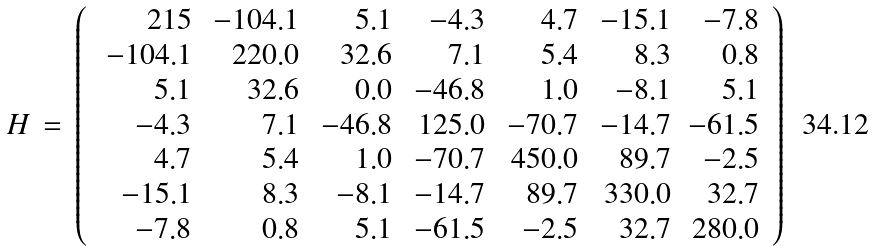<formula> <loc_0><loc_0><loc_500><loc_500>H \, = \, \left ( \, \begin{array} { r r r r r r r } 2 1 5 & \, - 1 0 4 . 1 & 5 . 1 & - 4 . 3 & 4 . 7 & - 1 5 . 1 & - 7 . 8 \\ \, - 1 0 4 . 1 & 2 2 0 . 0 & 3 2 . 6 & 7 . 1 & 5 . 4 & 8 . 3 & 0 . 8 \\ 5 . 1 & 3 2 . 6 & 0 . 0 & - 4 6 . 8 & 1 . 0 & - 8 . 1 & 5 . 1 \\ - 4 . 3 & 7 . 1 & \, - 4 6 . 8 & 1 2 5 . 0 & \, - 7 0 . 7 & \, - 1 4 . 7 & - 6 1 . 5 \\ 4 . 7 & 5 . 4 & 1 . 0 & \, - 7 0 . 7 & 4 5 0 . 0 & 8 9 . 7 & - 2 . 5 \\ - 1 5 . 1 & 8 . 3 & - 8 . 1 & - 1 4 . 7 & 8 9 . 7 & 3 3 0 . 0 & 3 2 . 7 \\ - 7 . 8 & 0 . 8 & 5 . 1 & - 6 1 . 5 & - 2 . 5 & 3 2 . 7 & 2 8 0 . 0 \end{array} \, \right )</formula> 